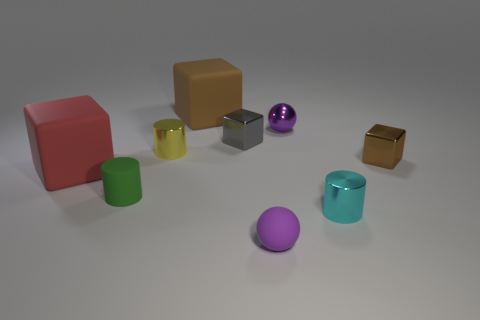Is there a small yellow metallic object of the same shape as the red object? After closely examining the image, I can confirm that there isn't a small yellow metallic object that matches the shape of the red object, which is a cube. There is, however, a small yellow object, but it appears to have a different shape, more like a small box rather than a cube. 